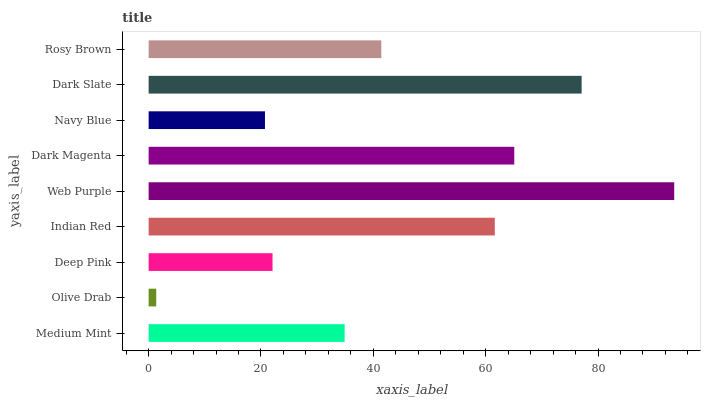Is Olive Drab the minimum?
Answer yes or no. Yes. Is Web Purple the maximum?
Answer yes or no. Yes. Is Deep Pink the minimum?
Answer yes or no. No. Is Deep Pink the maximum?
Answer yes or no. No. Is Deep Pink greater than Olive Drab?
Answer yes or no. Yes. Is Olive Drab less than Deep Pink?
Answer yes or no. Yes. Is Olive Drab greater than Deep Pink?
Answer yes or no. No. Is Deep Pink less than Olive Drab?
Answer yes or no. No. Is Rosy Brown the high median?
Answer yes or no. Yes. Is Rosy Brown the low median?
Answer yes or no. Yes. Is Dark Magenta the high median?
Answer yes or no. No. Is Olive Drab the low median?
Answer yes or no. No. 